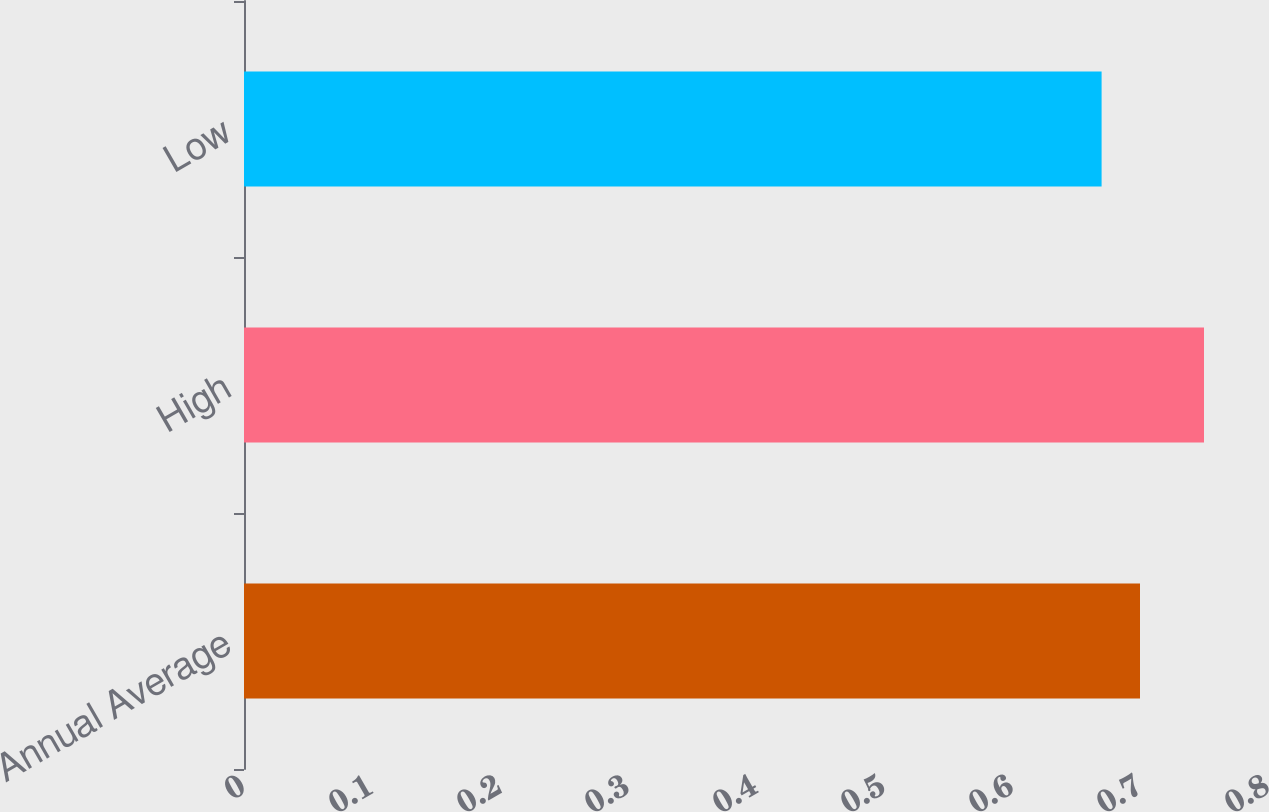Convert chart. <chart><loc_0><loc_0><loc_500><loc_500><bar_chart><fcel>Annual Average<fcel>High<fcel>Low<nl><fcel>0.7<fcel>0.75<fcel>0.67<nl></chart> 